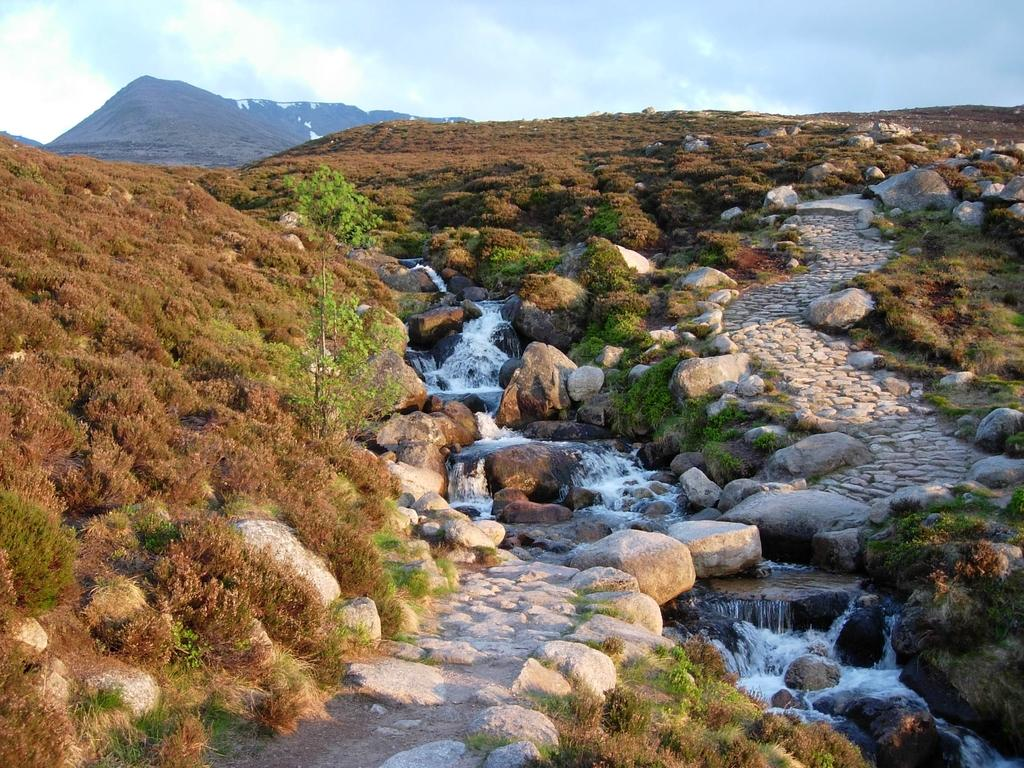What type of natural feature can be seen in the image? There is a stream in the image. What else can be found in the stream? There are rocks in the image. What type of vegetation is present in the image? There is greenery in the image. What is visible at the top of the image? The sky is visible at the top of the image. What can be seen in the sky? Clouds are present in the sky. What other large feature can be seen in the image? There is a mountain visible in the image. Where is the volleyball court located in the image? There is no volleyball court present in the image. What type of transportation can be seen in the image? There is no carriage or any other form of transportation present in the image. 